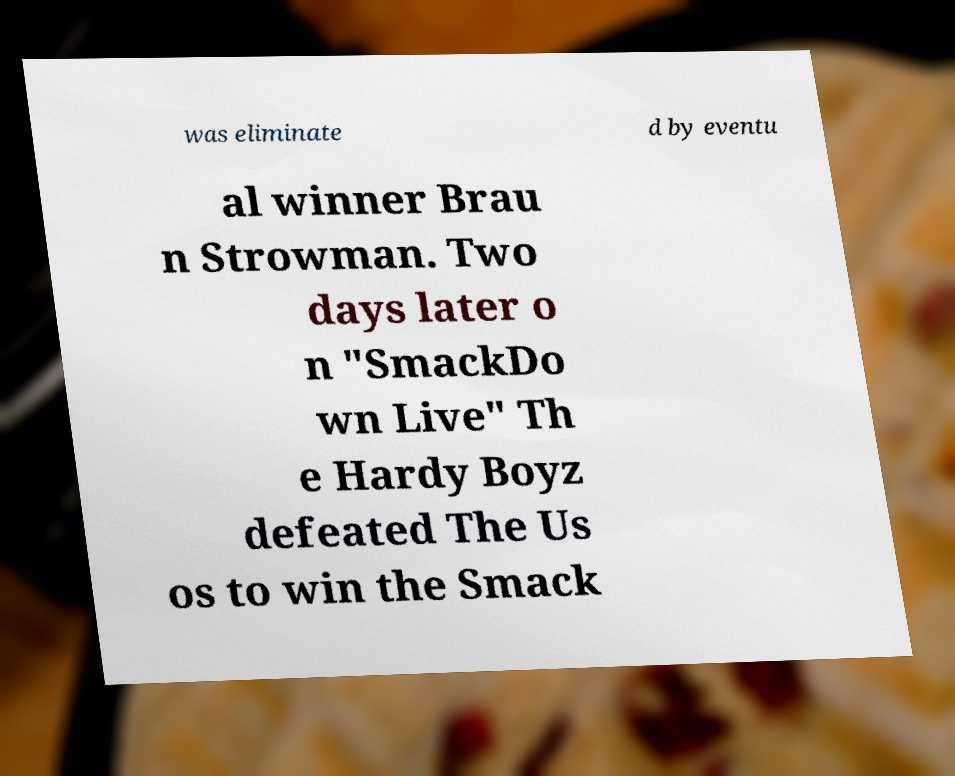Could you assist in decoding the text presented in this image and type it out clearly? was eliminate d by eventu al winner Brau n Strowman. Two days later o n "SmackDo wn Live" Th e Hardy Boyz defeated The Us os to win the Smack 